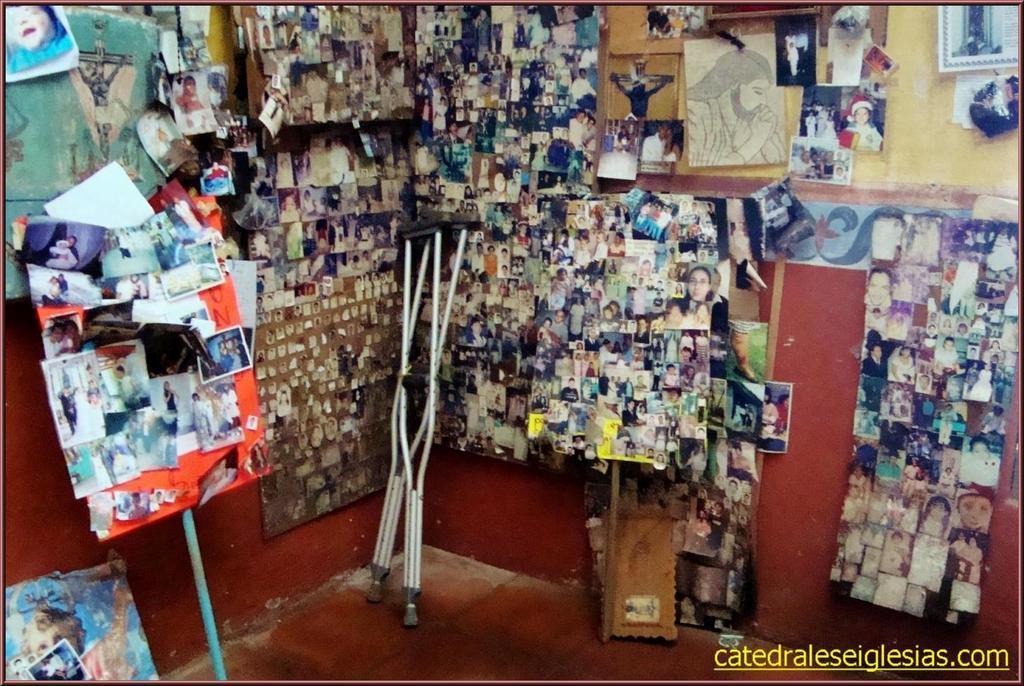What is present on the wall in the image? A group of photos is placed on the wall in the image. How many rods can be seen in the image? There are two rods in the image. What material is used for the wood-like object in the image? The wood material placed on the surface in the image is made of wood. What type of wire is used to hold the sugar in the image? There is no wire or sugar present in the image. How does the wood material look in the image? The wood material in the image is described as wood-like, but we cannot determine its appearance beyond that without additional information. 